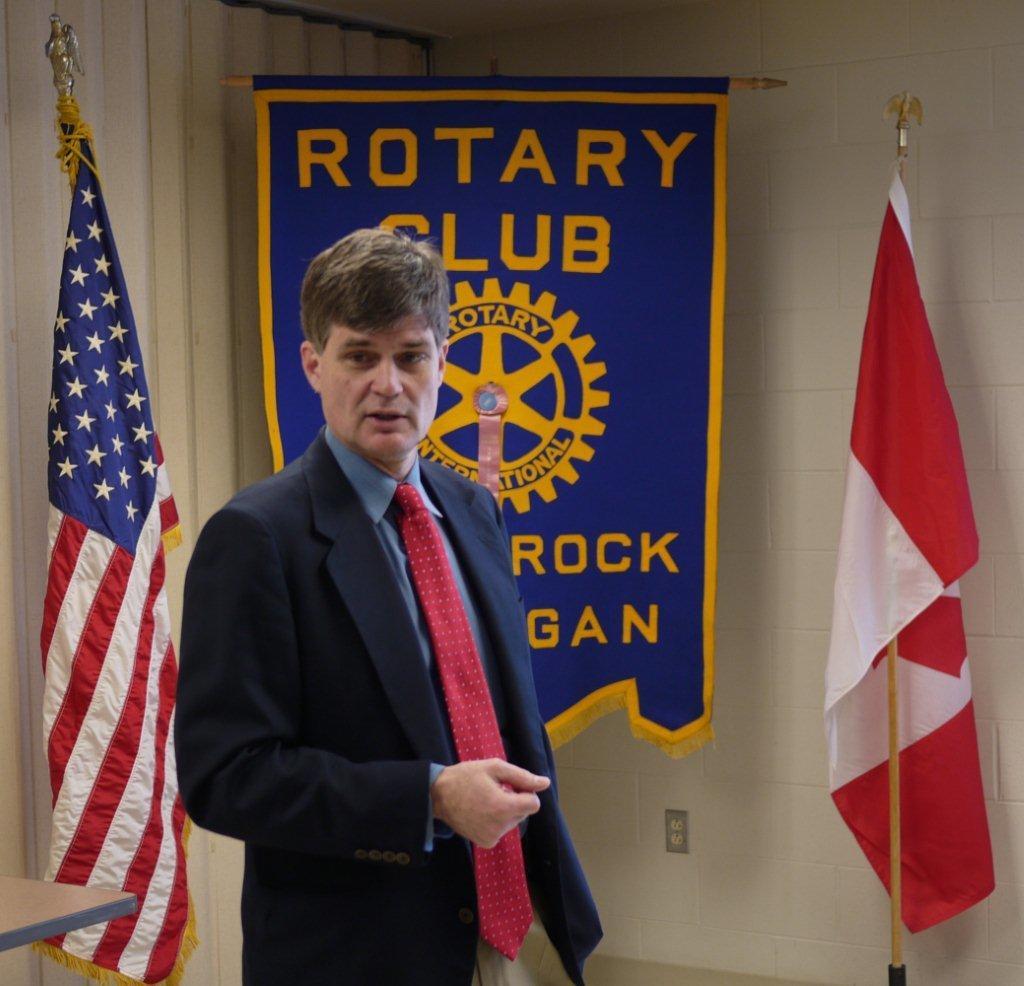In one or two sentences, can you explain what this image depicts? In this image, we can see person wearing cloth in front of the wall. There is a banner in the middle of the image. There is a flag on the left and on the right side of the image. 